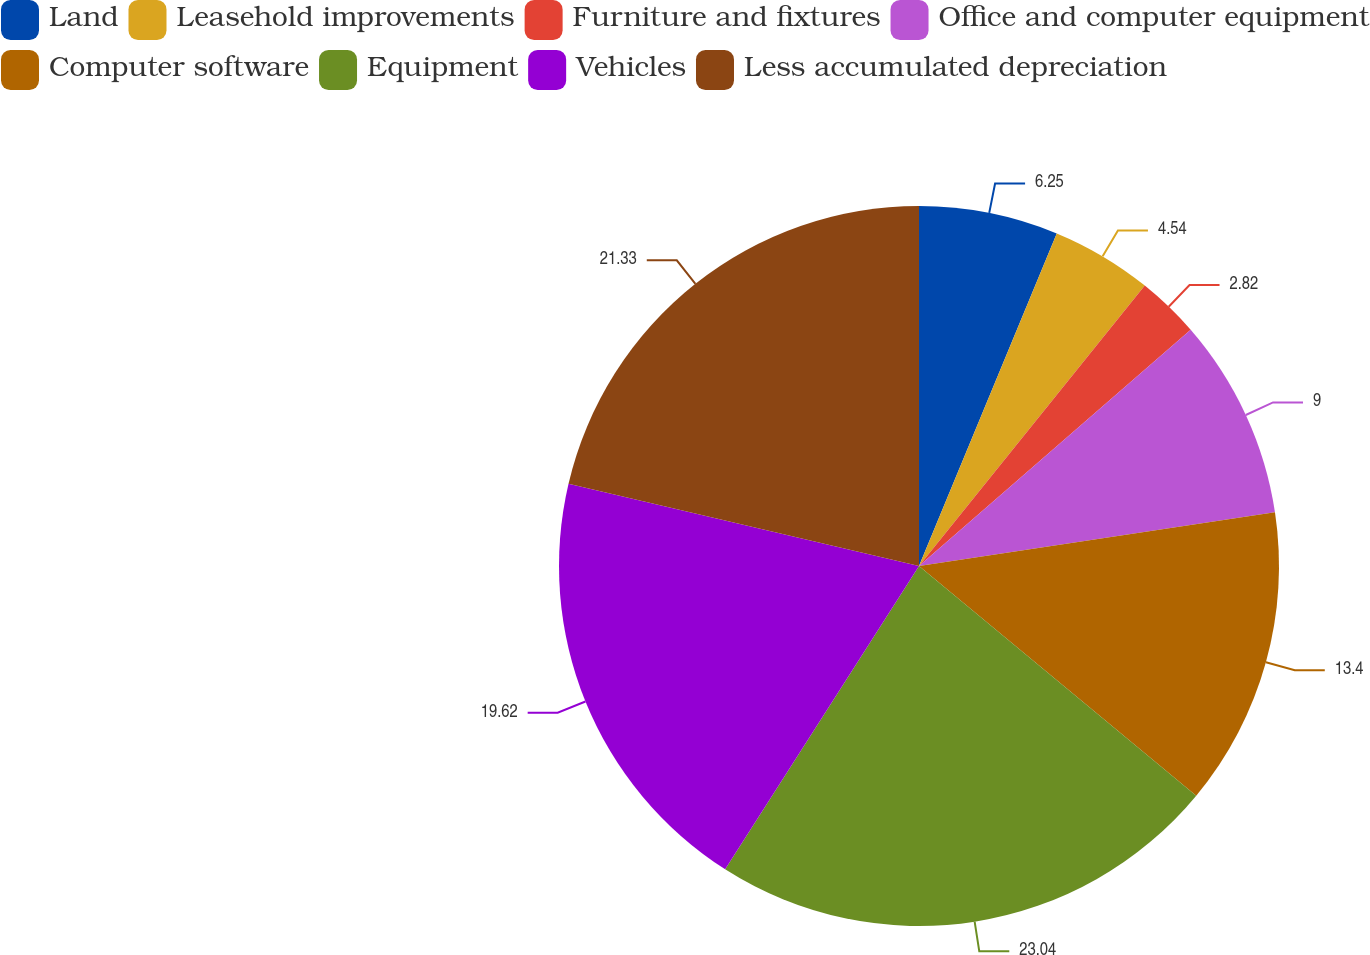Convert chart. <chart><loc_0><loc_0><loc_500><loc_500><pie_chart><fcel>Land<fcel>Leasehold improvements<fcel>Furniture and fixtures<fcel>Office and computer equipment<fcel>Computer software<fcel>Equipment<fcel>Vehicles<fcel>Less accumulated depreciation<nl><fcel>6.25%<fcel>4.54%<fcel>2.82%<fcel>9.0%<fcel>13.4%<fcel>23.04%<fcel>19.62%<fcel>21.33%<nl></chart> 